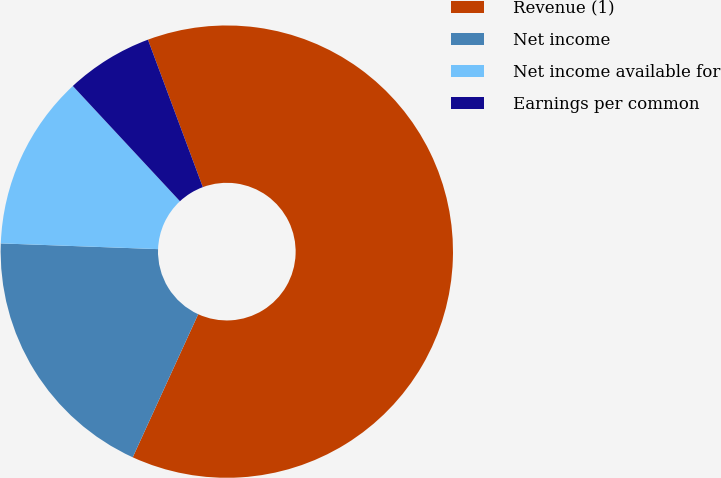Convert chart. <chart><loc_0><loc_0><loc_500><loc_500><pie_chart><fcel>Revenue (1)<fcel>Net income<fcel>Net income available for<fcel>Earnings per common<nl><fcel>62.5%<fcel>18.75%<fcel>12.5%<fcel>6.25%<nl></chart> 